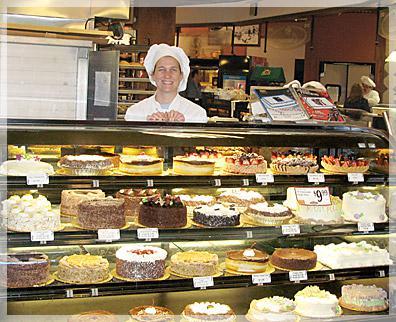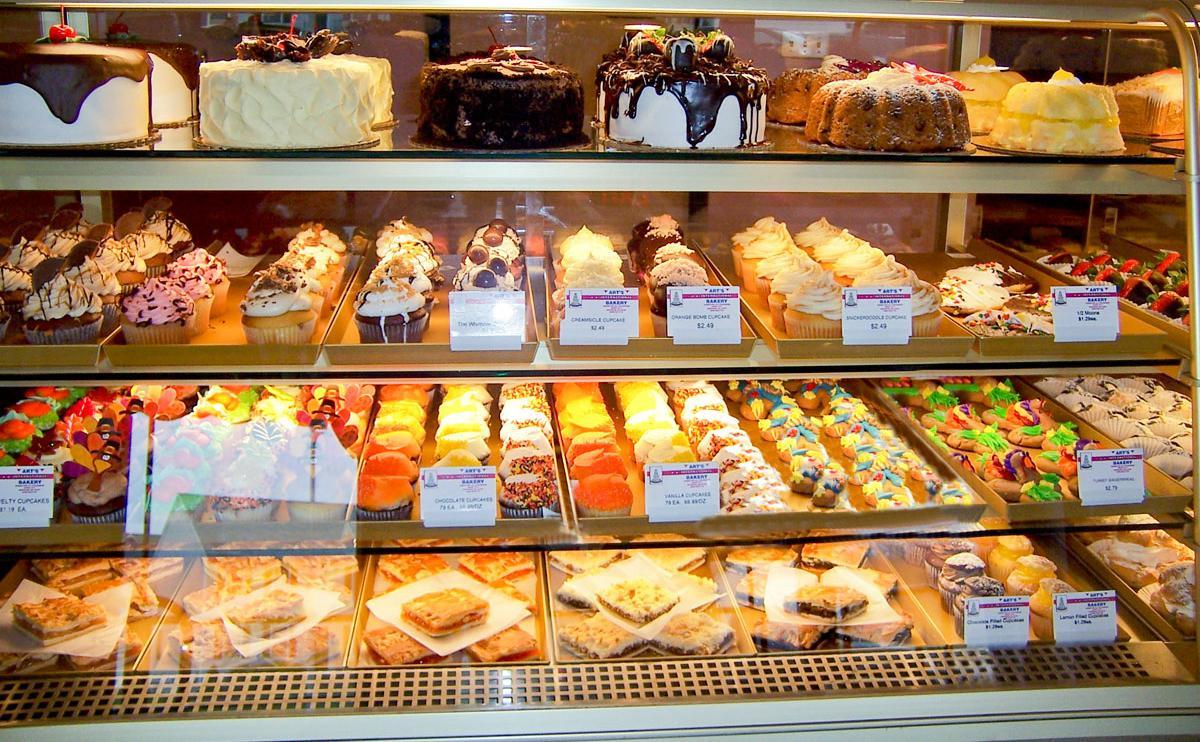The first image is the image on the left, the second image is the image on the right. Assess this claim about the two images: "At least one person is in one image behind a filled bakery display case with three or more shelves and a glass front". Correct or not? Answer yes or no. Yes. 